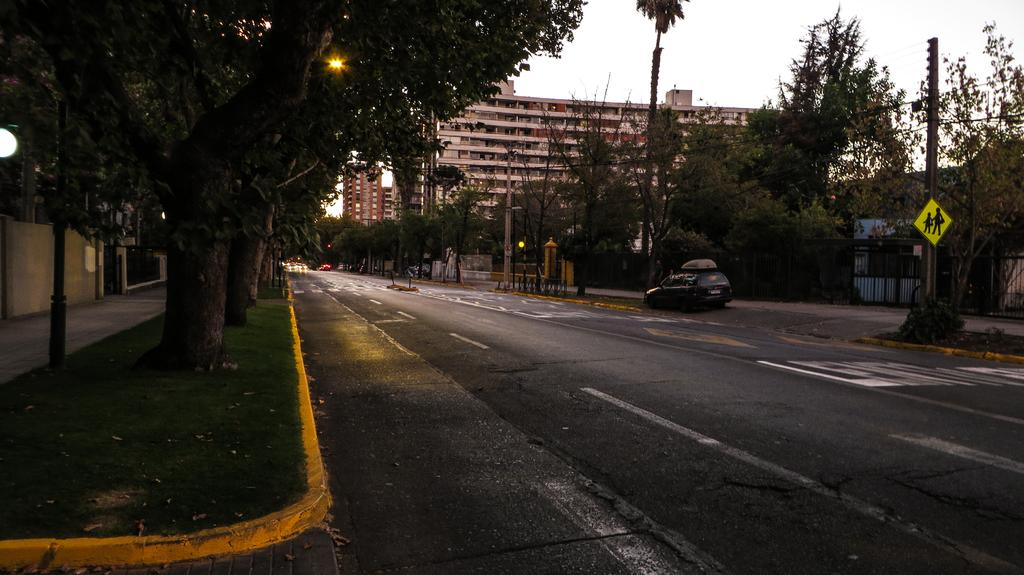What is the main feature of the image? There is a road in the image. What is happening on the road? A vehicle is present on the road. What else can be seen in the image besides the road and vehicle? There are buildings, a sign board, trees, electric poles, lights, and the sky visible in the image. What type of hat is the vehicle wearing in the image? There is no hat present in the image, as vehicles do not wear hats. 